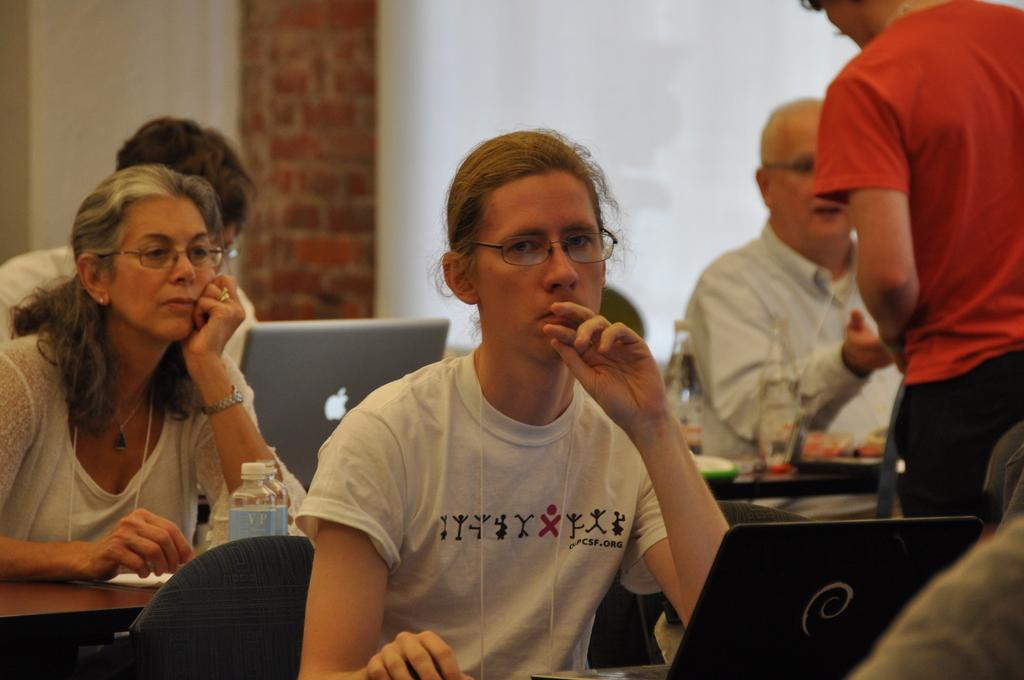What is happening in the image? There is a group of people in the image, and they are sitting on chairs. What objects are in front of the people? There are laptops and bottles in front of the people. What is the position of the person in the image? There is a person standing in front of the group. What can be seen in the background of the image? There is a wall in the background of the image. What type of soda is being served to the group in the image? There is no soda present in the image; only bottles are visible. What type of education is being provided to the group in the image? There is no indication of education being provided in the image; the people are simply sitting with laptops and bottles in front of them. 